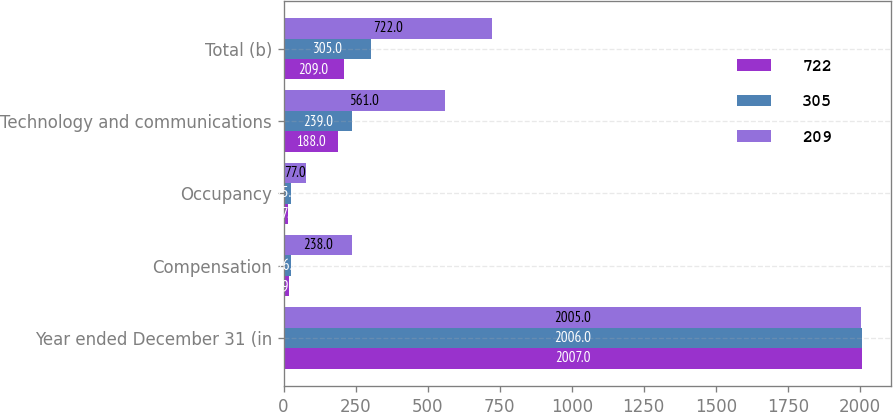<chart> <loc_0><loc_0><loc_500><loc_500><stacked_bar_chart><ecel><fcel>Year ended December 31 (in<fcel>Compensation<fcel>Occupancy<fcel>Technology and communications<fcel>Total (b)<nl><fcel>722<fcel>2007<fcel>19<fcel>17<fcel>188<fcel>209<nl><fcel>305<fcel>2006<fcel>26<fcel>25<fcel>239<fcel>305<nl><fcel>209<fcel>2005<fcel>238<fcel>77<fcel>561<fcel>722<nl></chart> 